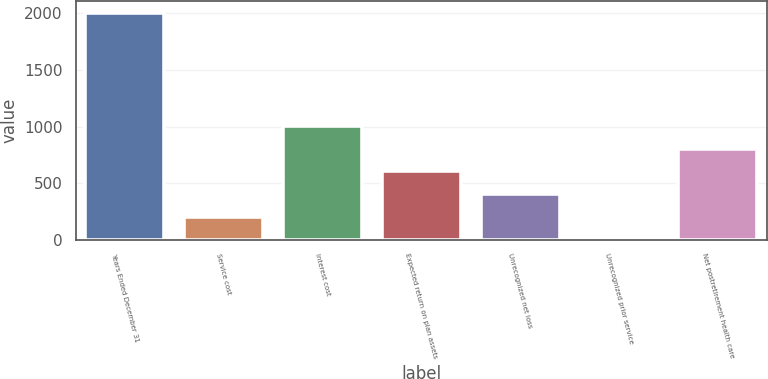Convert chart to OTSL. <chart><loc_0><loc_0><loc_500><loc_500><bar_chart><fcel>Years Ended December 31<fcel>Service cost<fcel>Interest cost<fcel>Expected return on plan assets<fcel>Unrecognized net loss<fcel>Unrecognized prior service<fcel>Net postretirement health care<nl><fcel>2006<fcel>202.4<fcel>1004<fcel>603.2<fcel>402.8<fcel>2<fcel>803.6<nl></chart> 